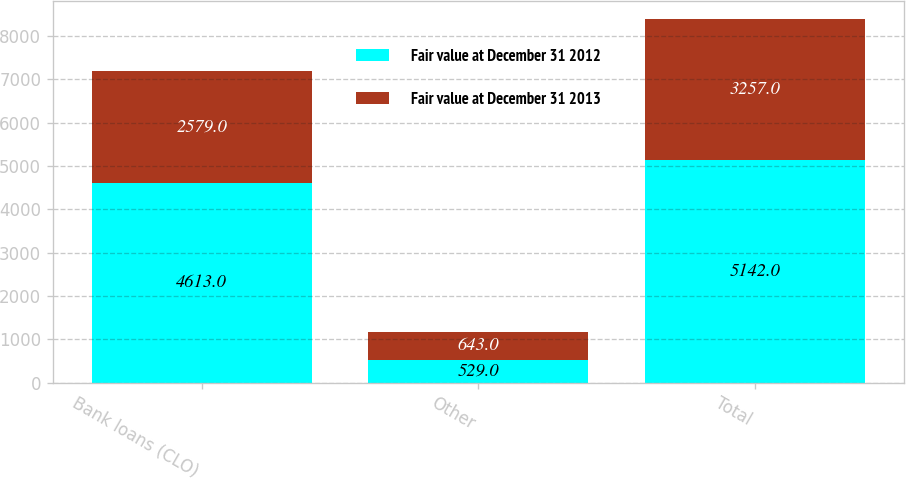Convert chart to OTSL. <chart><loc_0><loc_0><loc_500><loc_500><stacked_bar_chart><ecel><fcel>Bank loans (CLO)<fcel>Other<fcel>Total<nl><fcel>Fair value at December 31 2012<fcel>4613<fcel>529<fcel>5142<nl><fcel>Fair value at December 31 2013<fcel>2579<fcel>643<fcel>3257<nl></chart> 